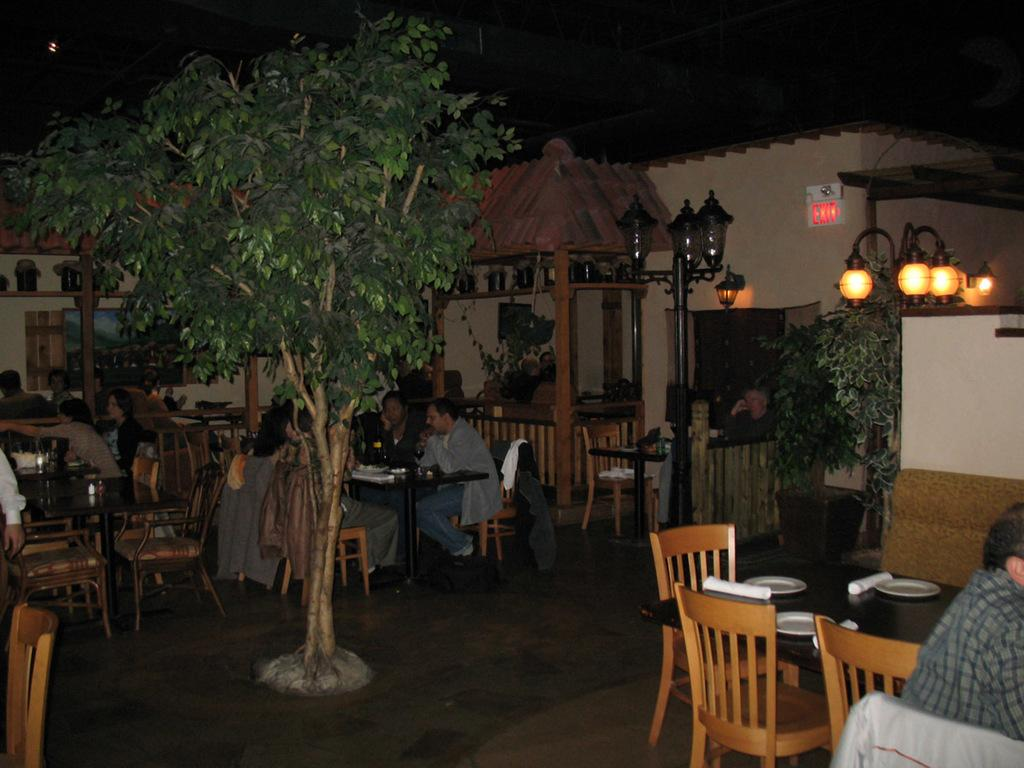What type of plant can be seen in the image? There is a tree in the image. What can be seen illuminating the area in the image? There are lights in the image. What type of furniture is present in the image? There is a chair and a table in the image. What items are on the table in the image? There are plates and napkins on the table in the image. Can you describe the person in the image? There is a person sitting in a chair in the background of the image. What is visible in the background of the image? There is a building in the background of the image. How does the earthquake affect the pot in the image? There is no earthquake or pot present in the image. What type of slip can be seen on the person's feet in the image? There is no slip or indication of footwear on the person in the image. 